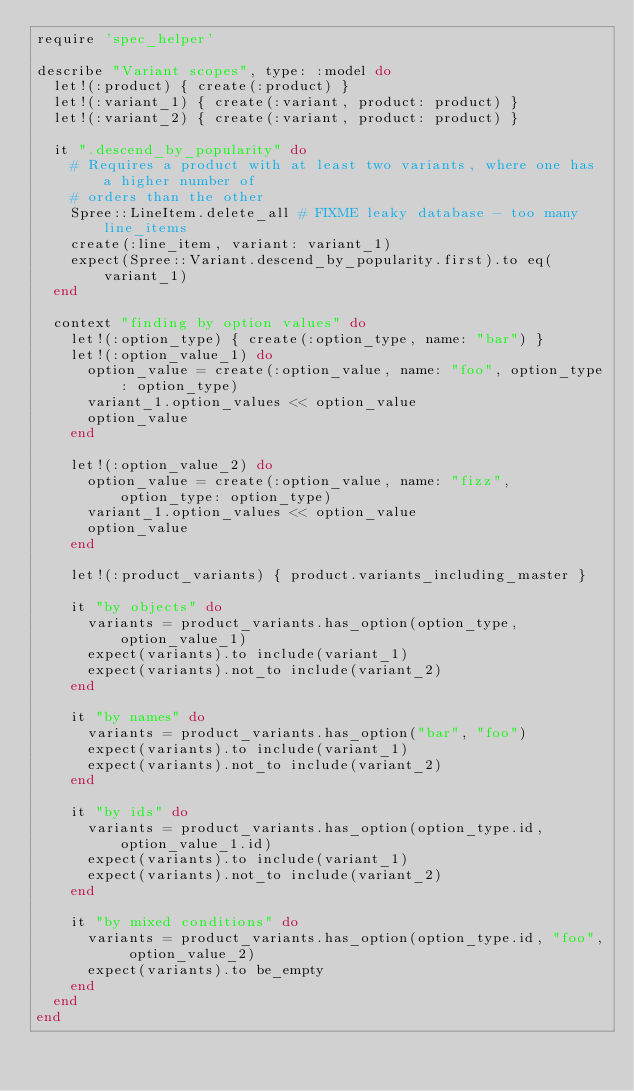Convert code to text. <code><loc_0><loc_0><loc_500><loc_500><_Ruby_>require 'spec_helper'

describe "Variant scopes", type: :model do
  let!(:product) { create(:product) }
  let!(:variant_1) { create(:variant, product: product) }
  let!(:variant_2) { create(:variant, product: product) }

  it ".descend_by_popularity" do
    # Requires a product with at least two variants, where one has a higher number of
    # orders than the other
    Spree::LineItem.delete_all # FIXME leaky database - too many line_items
    create(:line_item, variant: variant_1)
    expect(Spree::Variant.descend_by_popularity.first).to eq(variant_1)
  end

  context "finding by option values" do
    let!(:option_type) { create(:option_type, name: "bar") }
    let!(:option_value_1) do
      option_value = create(:option_value, name: "foo", option_type: option_type)
      variant_1.option_values << option_value
      option_value
    end

    let!(:option_value_2) do
      option_value = create(:option_value, name: "fizz", option_type: option_type)
      variant_1.option_values << option_value
      option_value
    end

    let!(:product_variants) { product.variants_including_master }

    it "by objects" do
      variants = product_variants.has_option(option_type, option_value_1)
      expect(variants).to include(variant_1)
      expect(variants).not_to include(variant_2)
    end

    it "by names" do
      variants = product_variants.has_option("bar", "foo")
      expect(variants).to include(variant_1)
      expect(variants).not_to include(variant_2)
    end

    it "by ids" do
      variants = product_variants.has_option(option_type.id, option_value_1.id)
      expect(variants).to include(variant_1)
      expect(variants).not_to include(variant_2)
    end

    it "by mixed conditions" do
      variants = product_variants.has_option(option_type.id, "foo", option_value_2)
      expect(variants).to be_empty
    end
  end
end
</code> 